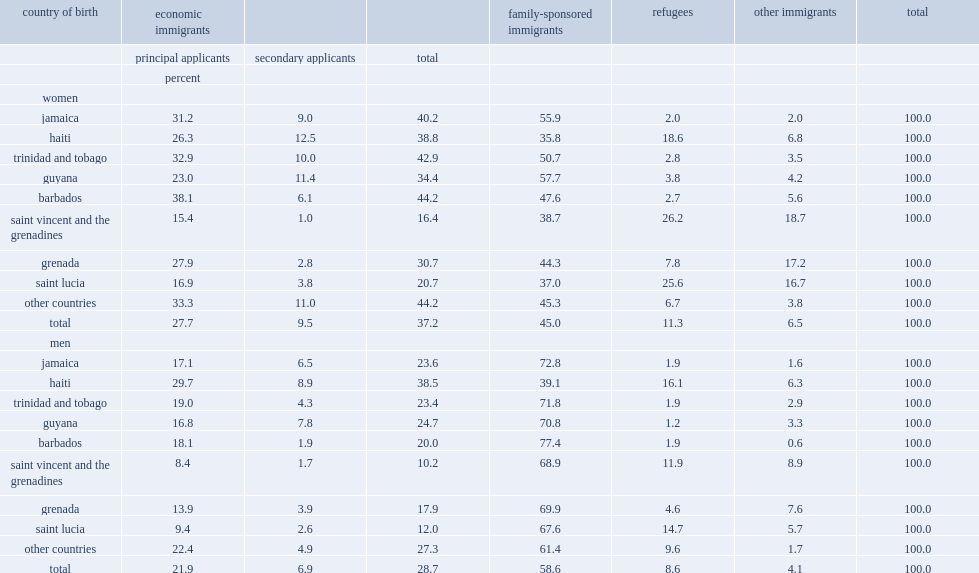Which had a higher proportion of admittances under the family sponsorship program,women or men? Men. 